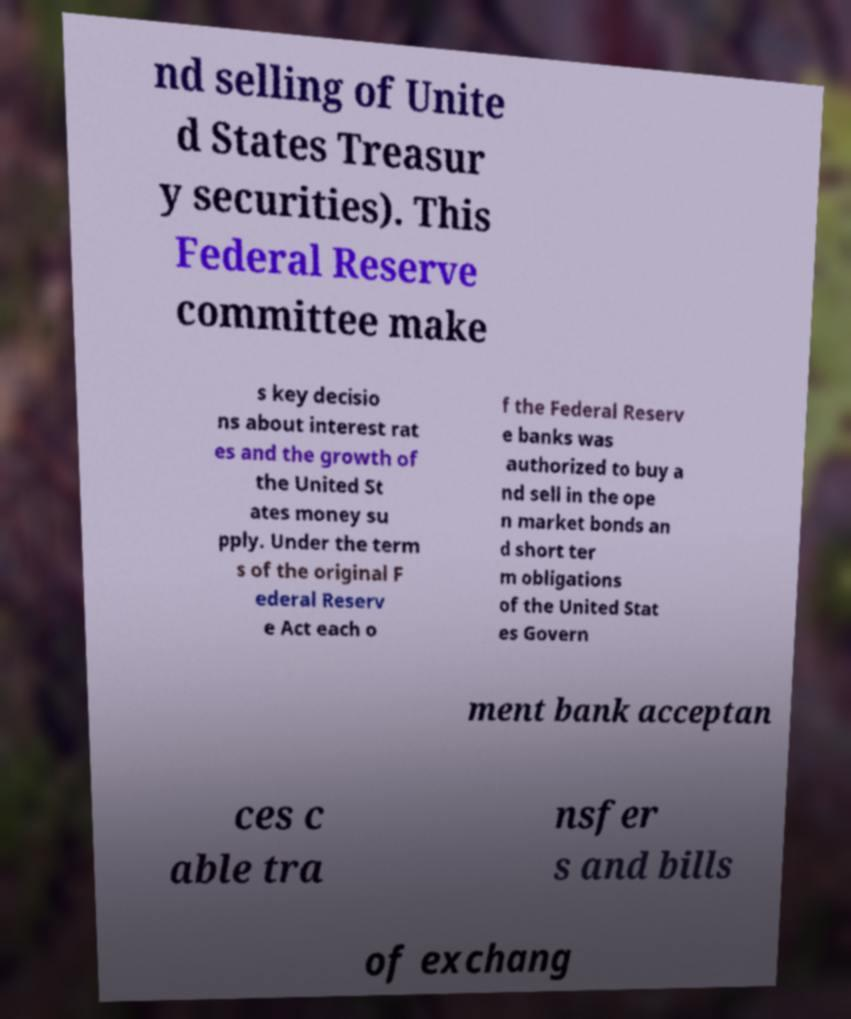There's text embedded in this image that I need extracted. Can you transcribe it verbatim? nd selling of Unite d States Treasur y securities). This Federal Reserve committee make s key decisio ns about interest rat es and the growth of the United St ates money su pply. Under the term s of the original F ederal Reserv e Act each o f the Federal Reserv e banks was authorized to buy a nd sell in the ope n market bonds an d short ter m obligations of the United Stat es Govern ment bank acceptan ces c able tra nsfer s and bills of exchang 